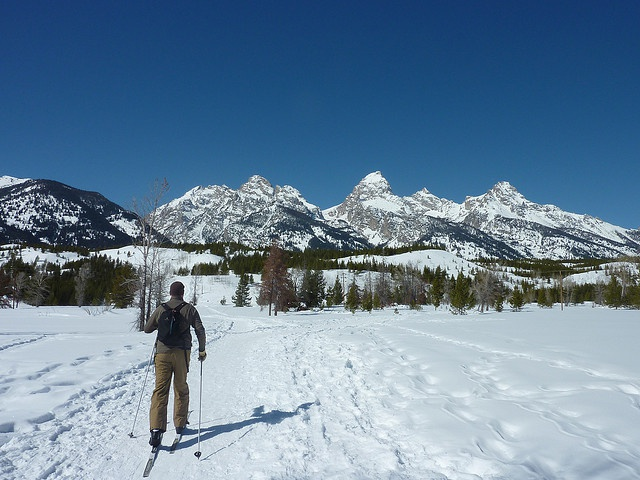Describe the objects in this image and their specific colors. I can see people in darkblue, black, and gray tones, backpack in darkblue, black, gray, and lightgray tones, and skis in darkblue, darkgray, lightgray, gray, and navy tones in this image. 